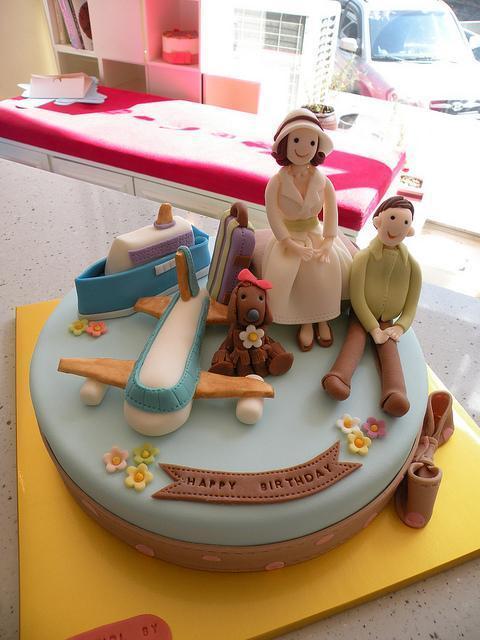How many dolls are on this cake?
Give a very brief answer. 3. How many of the cows are calves?
Give a very brief answer. 0. 